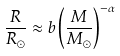Convert formula to latex. <formula><loc_0><loc_0><loc_500><loc_500>\frac { R } { R _ { \odot } } \approx b \left ( \frac { M } { M _ { \odot } } \right ) ^ { - \alpha }</formula> 